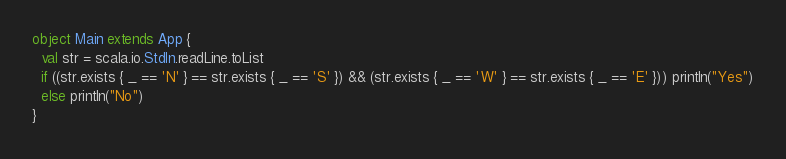Convert code to text. <code><loc_0><loc_0><loc_500><loc_500><_Scala_>object Main extends App {
  val str = scala.io.StdIn.readLine.toList
  if ((str.exists { _ == 'N' } == str.exists { _ == 'S' }) && (str.exists { _ == 'W' } == str.exists { _ == 'E' })) println("Yes")
  else println("No")
}</code> 